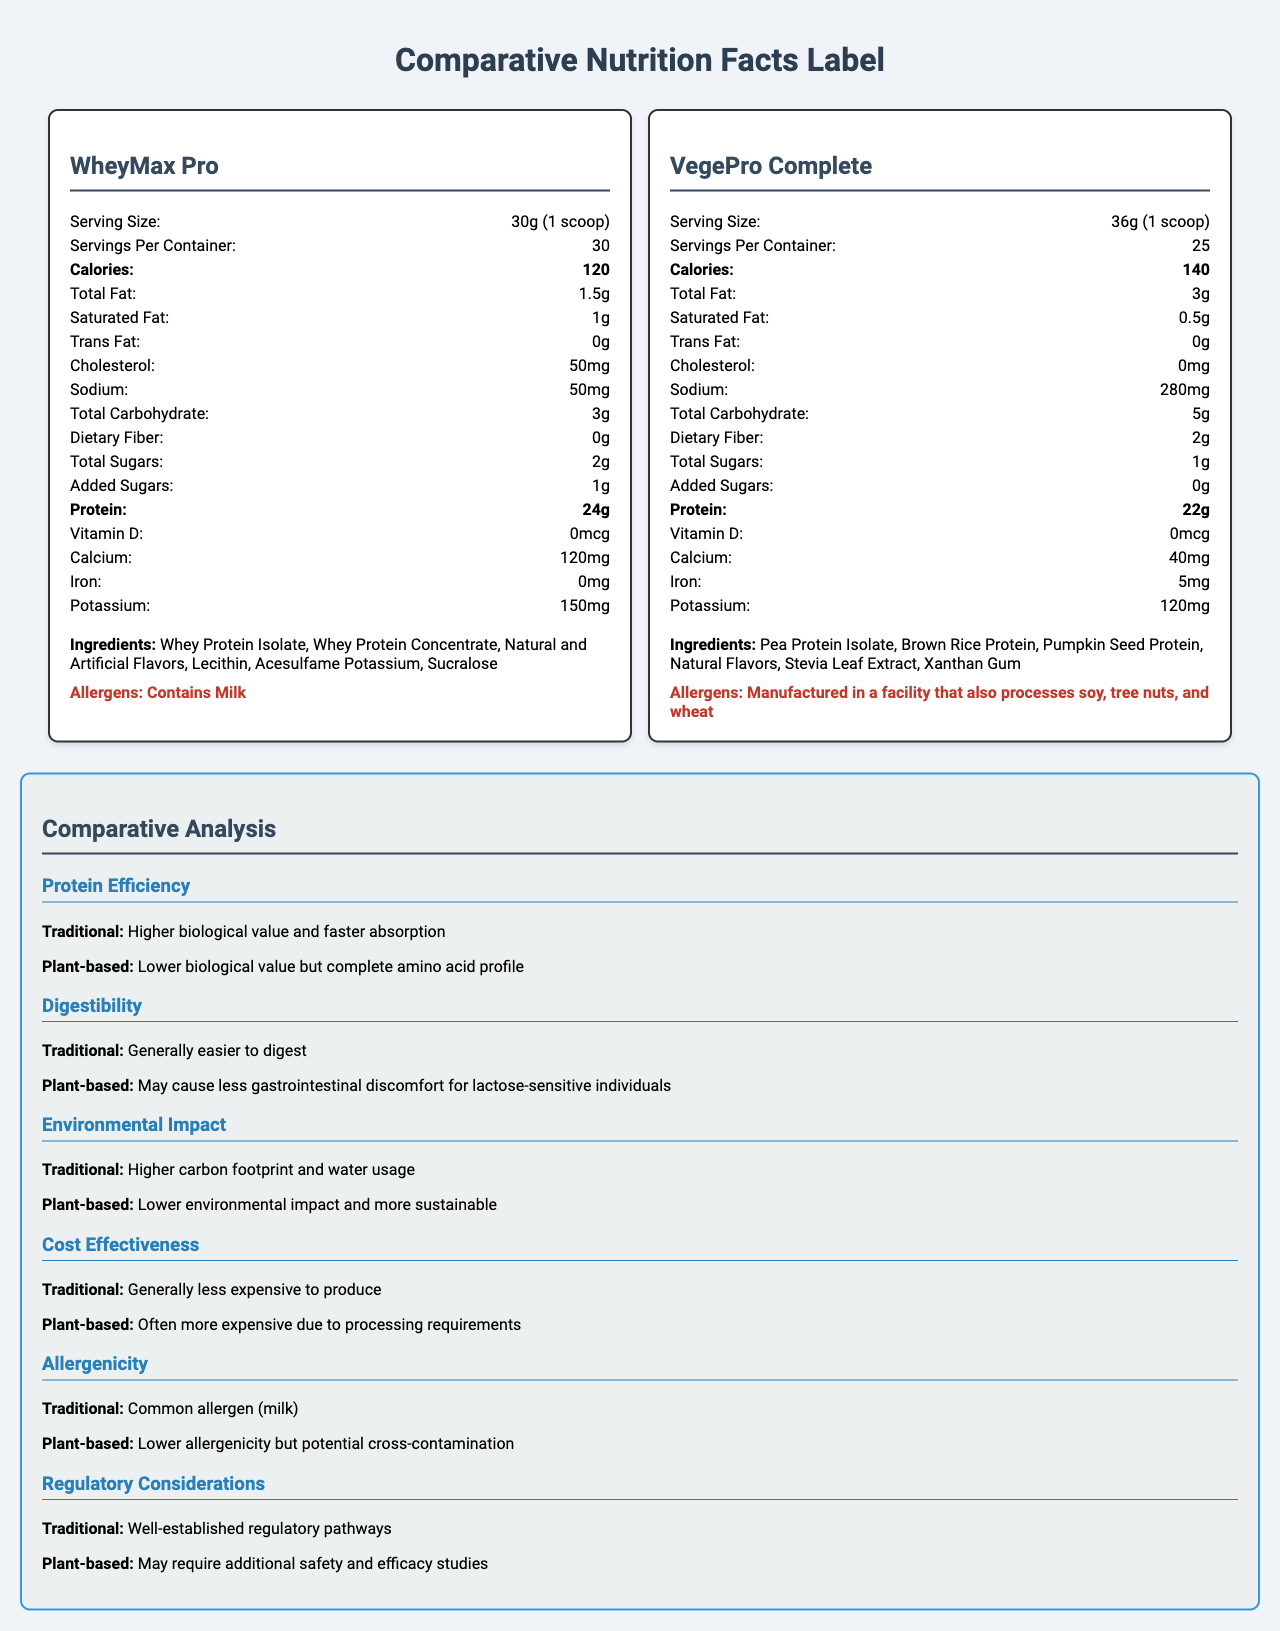what is the serving size of WheyMax Pro? The serving size is explicitly mentioned under the product heading for WheyMax Pro.
Answer: 30g (1 scoop) how many calories are in one serving of VegePro Complete? The calories per serving are listed in the nutritional facts section for VegePro Complete.
Answer: 140 what is the protein content per serving for WheyMax Pro? The protein amount is stated clearly in the nutrition facts for WheyMax Pro.
Answer: 24g which supplement has more servings per container and how many? WheyMax Pro lists 30 servings per container, while VegePro Complete lists 25 servings.
Answer: WheyMax Pro with 30 servings which supplement has higher sodium content per serving? VegePro Complete has 280mg of sodium per serving, compared to 50mg for WheyMax Pro.
Answer: VegePro Complete which supplement is lower in total fat per serving? A. WheyMax Pro B. VegePro Complete WheyMax Pro contains 1.5g of total fat per serving, while VegePro Complete contains 3g per serving.
Answer: A. WheyMax Pro what is one major allergen found in WheyMax Pro? A. Soy B. Tree Nuts C. Milk D. Wheat The allergen information for WheyMax Pro explicitly states "Contains Milk".
Answer: C. Milk do VegePro Complete contain any cholesterol? Yes/No VegePro Complete lists 0mg of cholesterol in the nutritional facts.
Answer: No what is the main idea of this document? The document provides a comparative analysis of nutritional facts and other characteristics of WheyMax Pro (a traditional protein supplement) and VegePro Complete (a plant-based protein supplement).
Answer: Comparative analysis between traditional and plant-based protein supplements which protein supplement is more sustainable according to the comparative analysis? The comparative analysis indicates that the plant-based supplement has a lower environmental impact and is more sustainable than the traditional one.
Answer: VegePro Complete what is the main sweetener used in VegePro Complete? The ingredient list for VegePro Complete includes Stevia Leaf Extract, suggesting it is the main sweetener used.
Answer: Stevia Leaf Extract why might the plant-based protein supplement be less allergenic? The comparative analysis highlights lower allergenicity for plant-based protein supplements compared to the traditional ones, yet there is potential for cross-contamination.
Answer: It has lower allergenicity but potential cross-contamination which supplement may better suit individuals with lactose sensitivity? The comparative analysis mentions that plant-based protein supplements may cause less gastrointestinal discomfort for lactose-sensitive individuals.
Answer: VegePro Complete which product contains more iron per serving, and how much? VegePro Complete has 5mg of iron per serving, whereas WheyMax Pro contains 0mg of iron.
Answer: VegePro Complete with 5mg are VegePro Complete manufactured in a dairy-free facility? The document only states that VegePro Complete is manufactured in a facility that processes soy, tree nuts, and wheat, but it does not explicitly mention if the facility is dairy-free.
Answer: Not enough information 